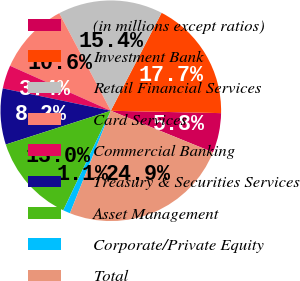Convert chart to OTSL. <chart><loc_0><loc_0><loc_500><loc_500><pie_chart><fcel>(in millions except ratios)<fcel>Investment Bank<fcel>Retail Financial Services<fcel>Card Services<fcel>Commercial Banking<fcel>Treasury & Securities Services<fcel>Asset Management<fcel>Corporate/Private Equity<fcel>Total<nl><fcel>5.81%<fcel>17.73%<fcel>15.35%<fcel>10.58%<fcel>3.43%<fcel>8.2%<fcel>12.96%<fcel>1.05%<fcel>24.88%<nl></chart> 